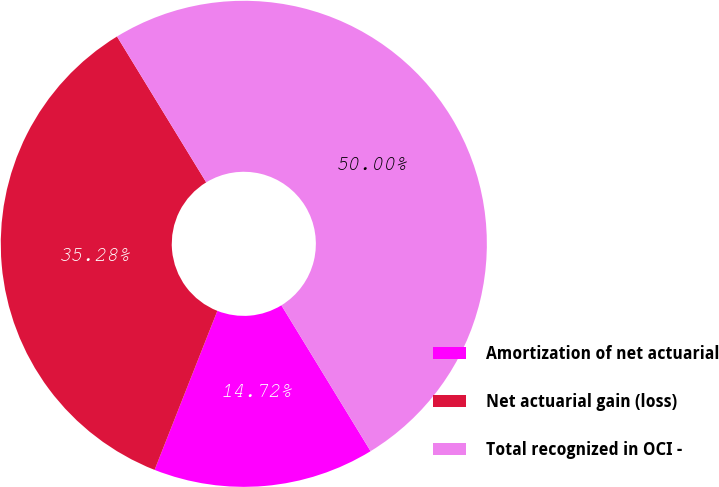<chart> <loc_0><loc_0><loc_500><loc_500><pie_chart><fcel>Amortization of net actuarial<fcel>Net actuarial gain (loss)<fcel>Total recognized in OCI -<nl><fcel>14.72%<fcel>35.28%<fcel>50.0%<nl></chart> 